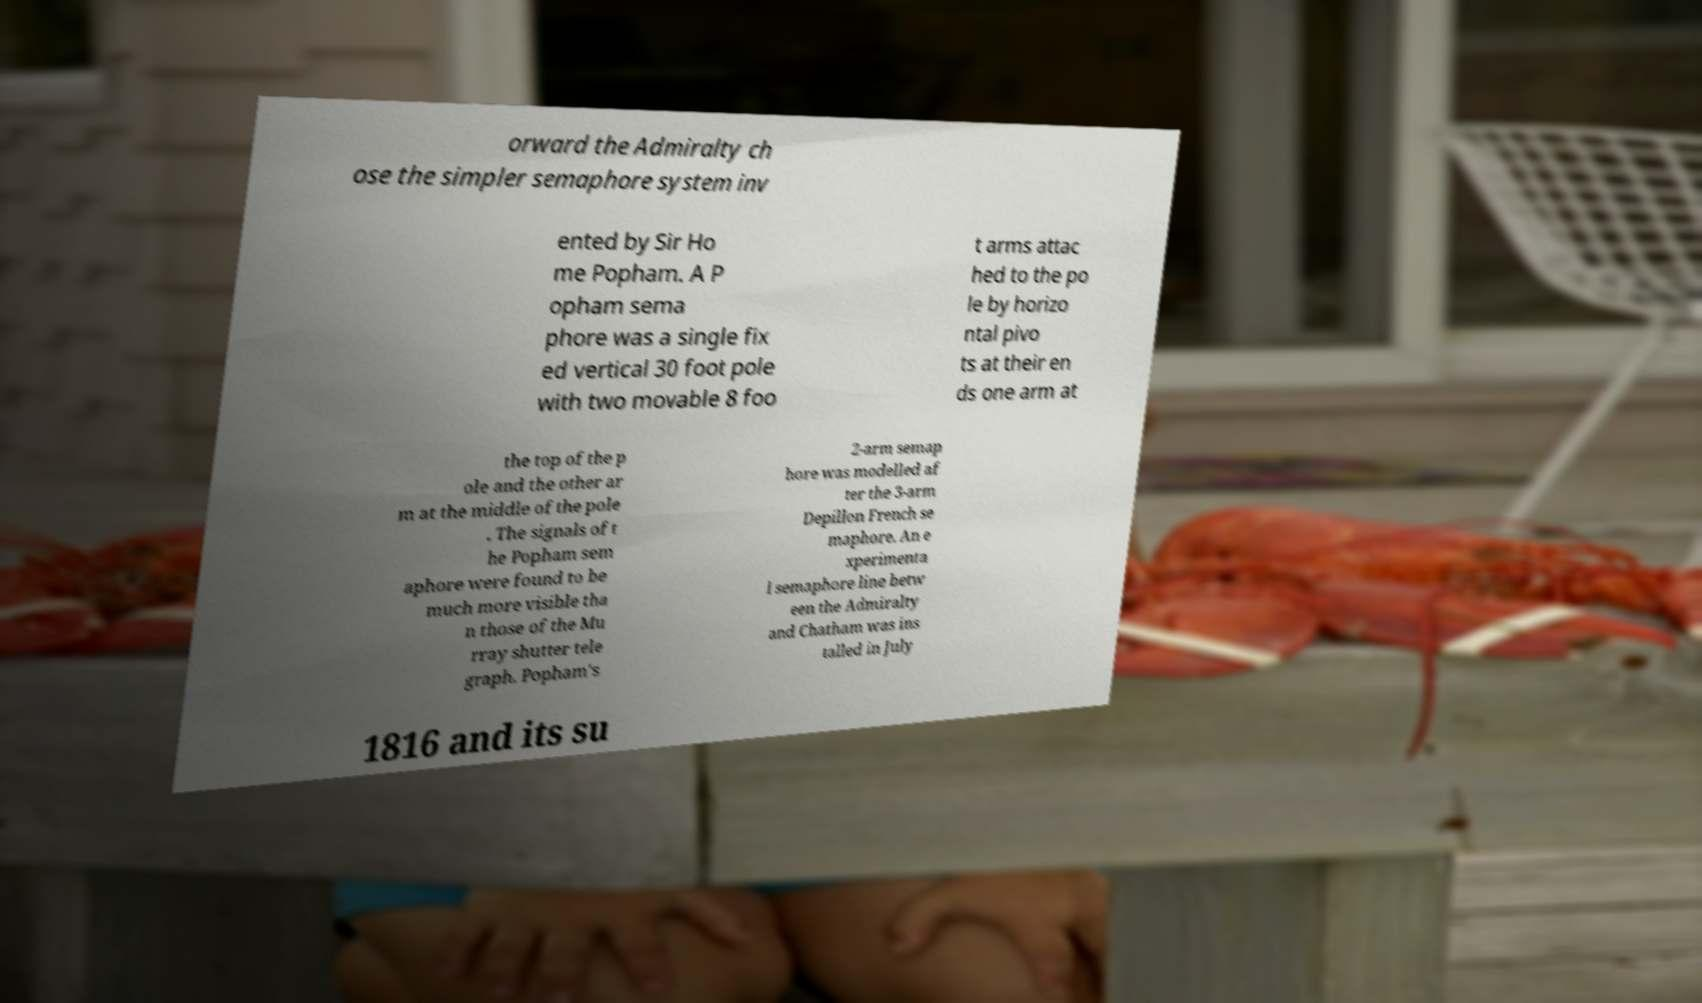Can you read and provide the text displayed in the image?This photo seems to have some interesting text. Can you extract and type it out for me? orward the Admiralty ch ose the simpler semaphore system inv ented by Sir Ho me Popham. A P opham sema phore was a single fix ed vertical 30 foot pole with two movable 8 foo t arms attac hed to the po le by horizo ntal pivo ts at their en ds one arm at the top of the p ole and the other ar m at the middle of the pole . The signals of t he Popham sem aphore were found to be much more visible tha n those of the Mu rray shutter tele graph. Popham's 2-arm semap hore was modelled af ter the 3-arm Depillon French se maphore. An e xperimenta l semaphore line betw een the Admiralty and Chatham was ins talled in July 1816 and its su 